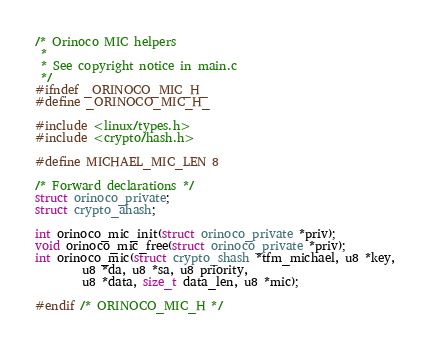<code> <loc_0><loc_0><loc_500><loc_500><_C_>/* Orinoco MIC helpers
 *
 * See copyright notice in main.c
 */
#ifndef _ORINOCO_MIC_H_
#define _ORINOCO_MIC_H_

#include <linux/types.h>
#include <crypto/hash.h>

#define MICHAEL_MIC_LEN 8

/* Forward declarations */
struct orinoco_private;
struct crypto_ahash;

int orinoco_mic_init(struct orinoco_private *priv);
void orinoco_mic_free(struct orinoco_private *priv);
int orinoco_mic(struct crypto_shash *tfm_michael, u8 *key,
		u8 *da, u8 *sa, u8 priority,
		u8 *data, size_t data_len, u8 *mic);

#endif /* ORINOCO_MIC_H */
</code> 